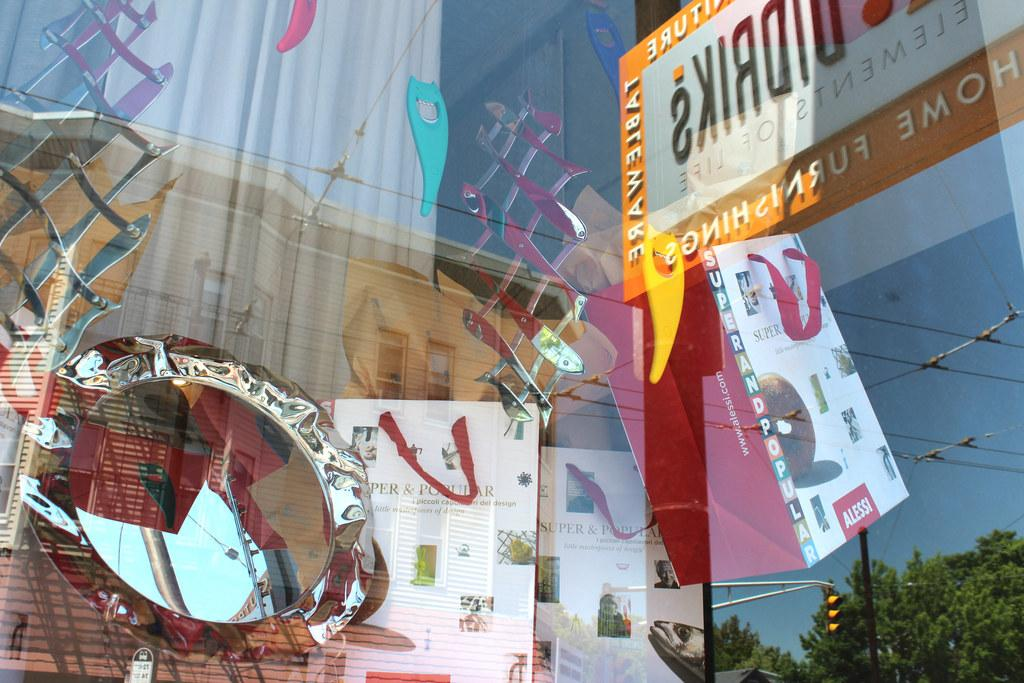What objects can be seen in the image that are used for carrying items? There are bags in the image that are used for carrying items. What object in the image can be used for personal grooming? There is a mirror in the image that can be used for personal grooming. What type of window treatment is visible through the glass door in the image? There is a curtain visible through the glass door in the image. What type of electrical connections are present in the image? There are cables in the image that represent electrical connections. What type of traffic control device is visible in the image? There are traffic lights in the image that serve as traffic control devices. What type of natural vegetation is visible in the image? There are trees in the image that represent natural vegetation. What type of structural support is visible in the image? There are metal rods in the image that serve as structural support. What angle is the history book leaning at in the image? There is no history book present in the image. What type of trees are visible in the image, and what historical events are they associated with? There are trees in the image, but they are not associated with any specific historical events. 